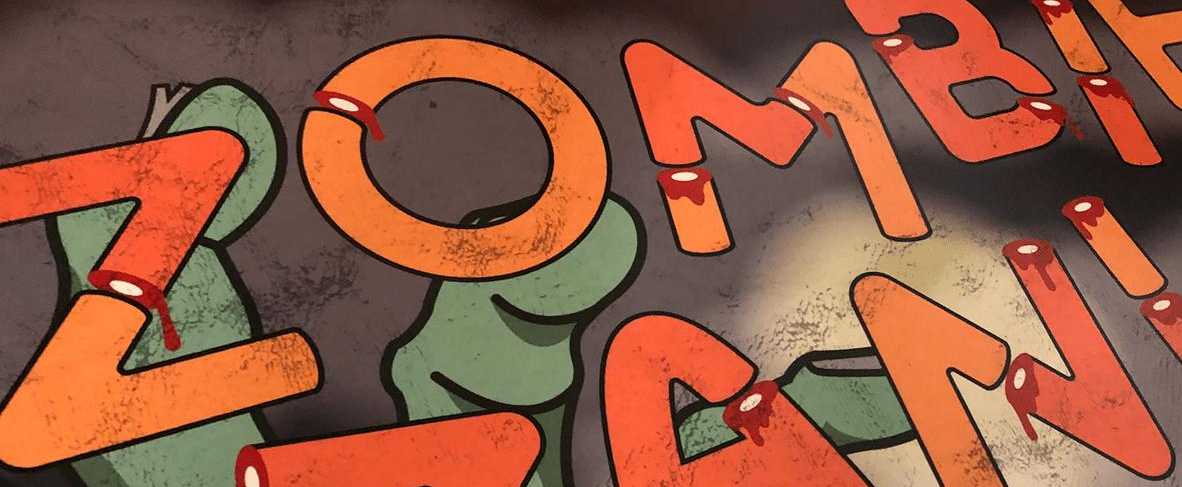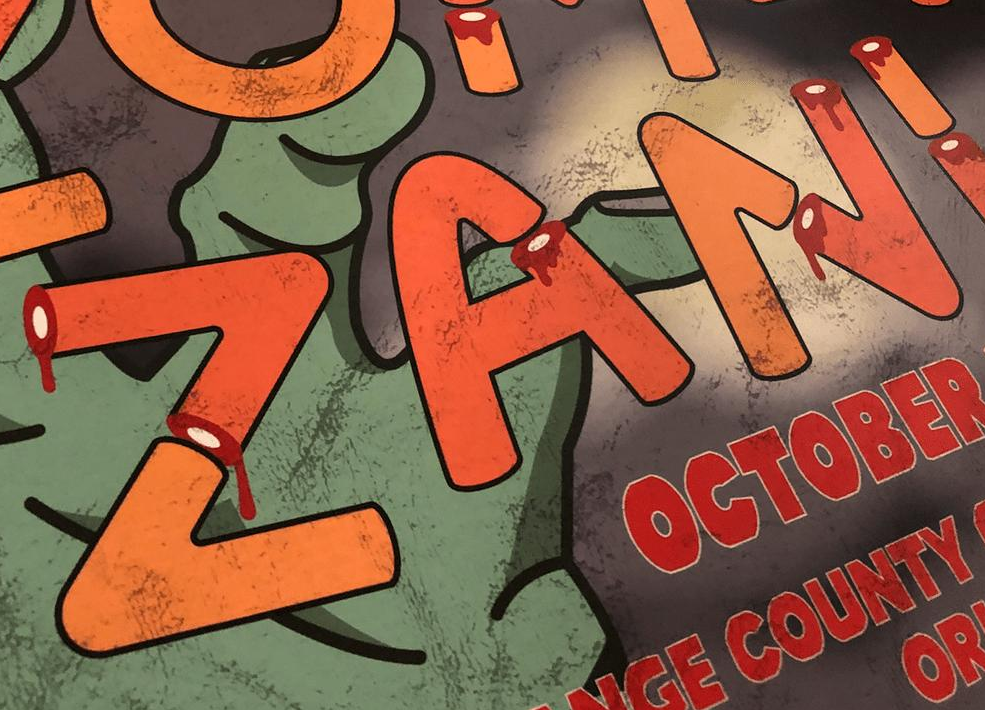Transcribe the words shown in these images in order, separated by a semicolon. ZOMBI; ZANI 